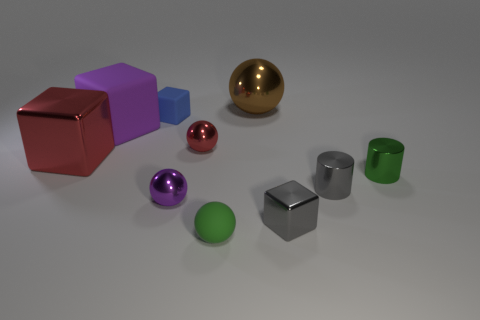Subtract 1 spheres. How many spheres are left? 3 Subtract all balls. How many objects are left? 6 Add 4 large metal spheres. How many large metal spheres are left? 5 Add 4 green matte objects. How many green matte objects exist? 5 Subtract 0 purple cylinders. How many objects are left? 10 Subtract all purple balls. Subtract all small gray shiny things. How many objects are left? 7 